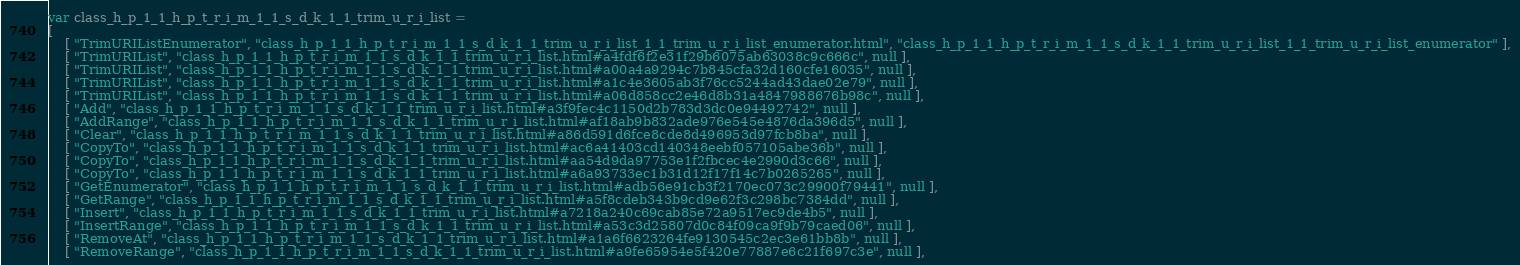<code> <loc_0><loc_0><loc_500><loc_500><_JavaScript_>var class_h_p_1_1_h_p_t_r_i_m_1_1_s_d_k_1_1_trim_u_r_i_list =
[
    [ "TrimURIListEnumerator", "class_h_p_1_1_h_p_t_r_i_m_1_1_s_d_k_1_1_trim_u_r_i_list_1_1_trim_u_r_i_list_enumerator.html", "class_h_p_1_1_h_p_t_r_i_m_1_1_s_d_k_1_1_trim_u_r_i_list_1_1_trim_u_r_i_list_enumerator" ],
    [ "TrimURIList", "class_h_p_1_1_h_p_t_r_i_m_1_1_s_d_k_1_1_trim_u_r_i_list.html#a4fdf6f2e31f29b6075ab63038c9c666c", null ],
    [ "TrimURIList", "class_h_p_1_1_h_p_t_r_i_m_1_1_s_d_k_1_1_trim_u_r_i_list.html#a00a4a9294c7b845cfa32d160cfe16035", null ],
    [ "TrimURIList", "class_h_p_1_1_h_p_t_r_i_m_1_1_s_d_k_1_1_trim_u_r_i_list.html#a1c4e3605ab3f76cc5244ad43dae02e79", null ],
    [ "TrimURIList", "class_h_p_1_1_h_p_t_r_i_m_1_1_s_d_k_1_1_trim_u_r_i_list.html#a06d858cc2e46d8b31a4847988676b98c", null ],
    [ "Add", "class_h_p_1_1_h_p_t_r_i_m_1_1_s_d_k_1_1_trim_u_r_i_list.html#a3f9fec4c1150d2b783d3dc0e94492742", null ],
    [ "AddRange", "class_h_p_1_1_h_p_t_r_i_m_1_1_s_d_k_1_1_trim_u_r_i_list.html#af18ab9b832ade976e545e4876da396d5", null ],
    [ "Clear", "class_h_p_1_1_h_p_t_r_i_m_1_1_s_d_k_1_1_trim_u_r_i_list.html#a86d591d6fce8cde8d496953d97fcb8ba", null ],
    [ "CopyTo", "class_h_p_1_1_h_p_t_r_i_m_1_1_s_d_k_1_1_trim_u_r_i_list.html#ac6a41403cd140348eebf057105abe36b", null ],
    [ "CopyTo", "class_h_p_1_1_h_p_t_r_i_m_1_1_s_d_k_1_1_trim_u_r_i_list.html#aa54d9da97753e1f2fbcec4e2990d3c66", null ],
    [ "CopyTo", "class_h_p_1_1_h_p_t_r_i_m_1_1_s_d_k_1_1_trim_u_r_i_list.html#a6a93733ec1b31d12f17f14c7b0265265", null ],
    [ "GetEnumerator", "class_h_p_1_1_h_p_t_r_i_m_1_1_s_d_k_1_1_trim_u_r_i_list.html#adb56e91cb3f2170ec073c29900f79441", null ],
    [ "GetRange", "class_h_p_1_1_h_p_t_r_i_m_1_1_s_d_k_1_1_trim_u_r_i_list.html#a5f8cdeb343b9cd9e62f3c298bc7384dd", null ],
    [ "Insert", "class_h_p_1_1_h_p_t_r_i_m_1_1_s_d_k_1_1_trim_u_r_i_list.html#a7218a240c69cab85e72a9517ec9de4b5", null ],
    [ "InsertRange", "class_h_p_1_1_h_p_t_r_i_m_1_1_s_d_k_1_1_trim_u_r_i_list.html#a53c3d25807d0c84f09ca9f9b79caed06", null ],
    [ "RemoveAt", "class_h_p_1_1_h_p_t_r_i_m_1_1_s_d_k_1_1_trim_u_r_i_list.html#a1a6f6623264fe9130545c2ec3e61bb8b", null ],
    [ "RemoveRange", "class_h_p_1_1_h_p_t_r_i_m_1_1_s_d_k_1_1_trim_u_r_i_list.html#a9fe65954e5f420e77887e6c21f697c3e", null ],</code> 